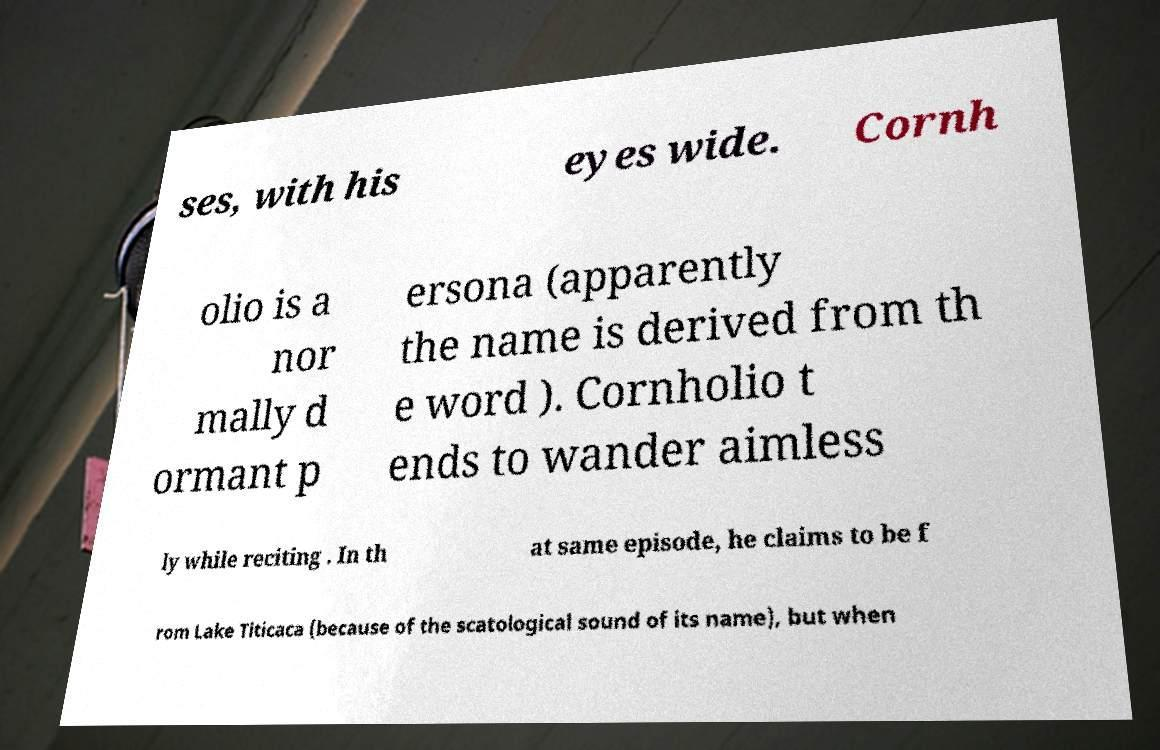Can you read and provide the text displayed in the image?This photo seems to have some interesting text. Can you extract and type it out for me? ses, with his eyes wide. Cornh olio is a nor mally d ormant p ersona (apparently the name is derived from th e word ). Cornholio t ends to wander aimless ly while reciting . In th at same episode, he claims to be f rom Lake Titicaca (because of the scatological sound of its name), but when 